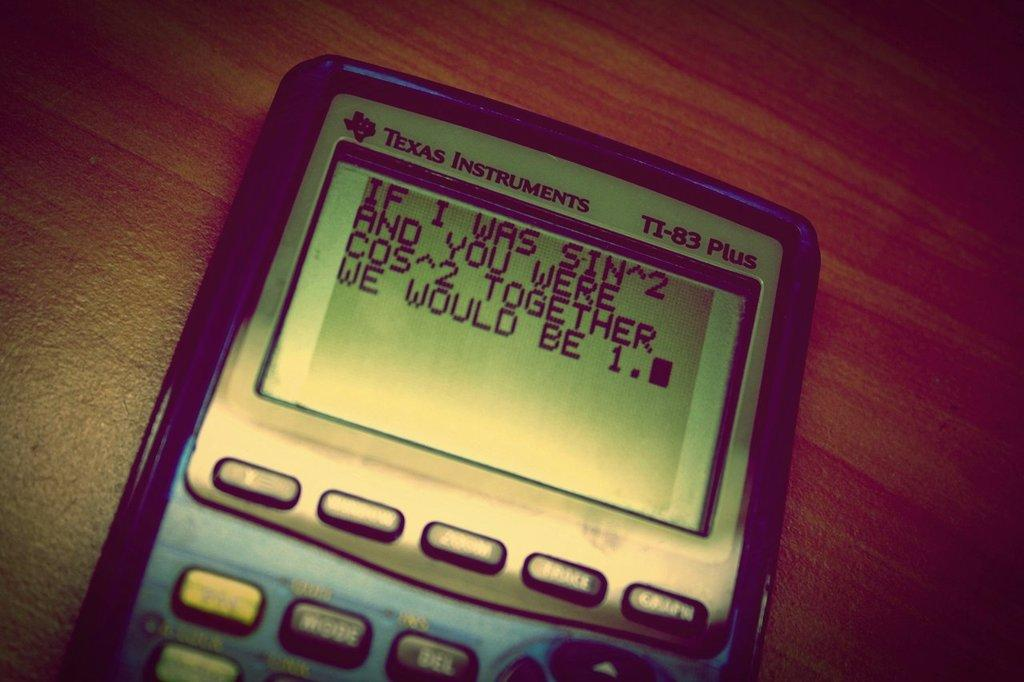What object is on the table in the image? There is an instrument on the table. What feature does the instrument have? The instrument has a digital screen. What is displayed on the digital screen? The digital screen displays text. How can the instrument be interacted with? The instrument has buttons. What type of clover is growing on the table in the image? There is no clover present in the image; the main subject is an instrument with a digital screen. What fruit is being used to interact with the buttons on the instrument? There is no fruit present in the image; the instrument has buttons that can be pressed by fingers or other objects. 